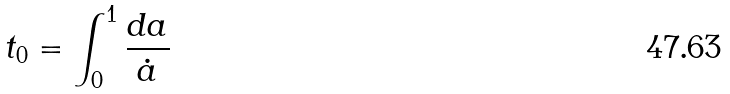Convert formula to latex. <formula><loc_0><loc_0><loc_500><loc_500>t _ { 0 } = \int _ { 0 } ^ { 1 } \frac { d a } { \dot { a } }</formula> 